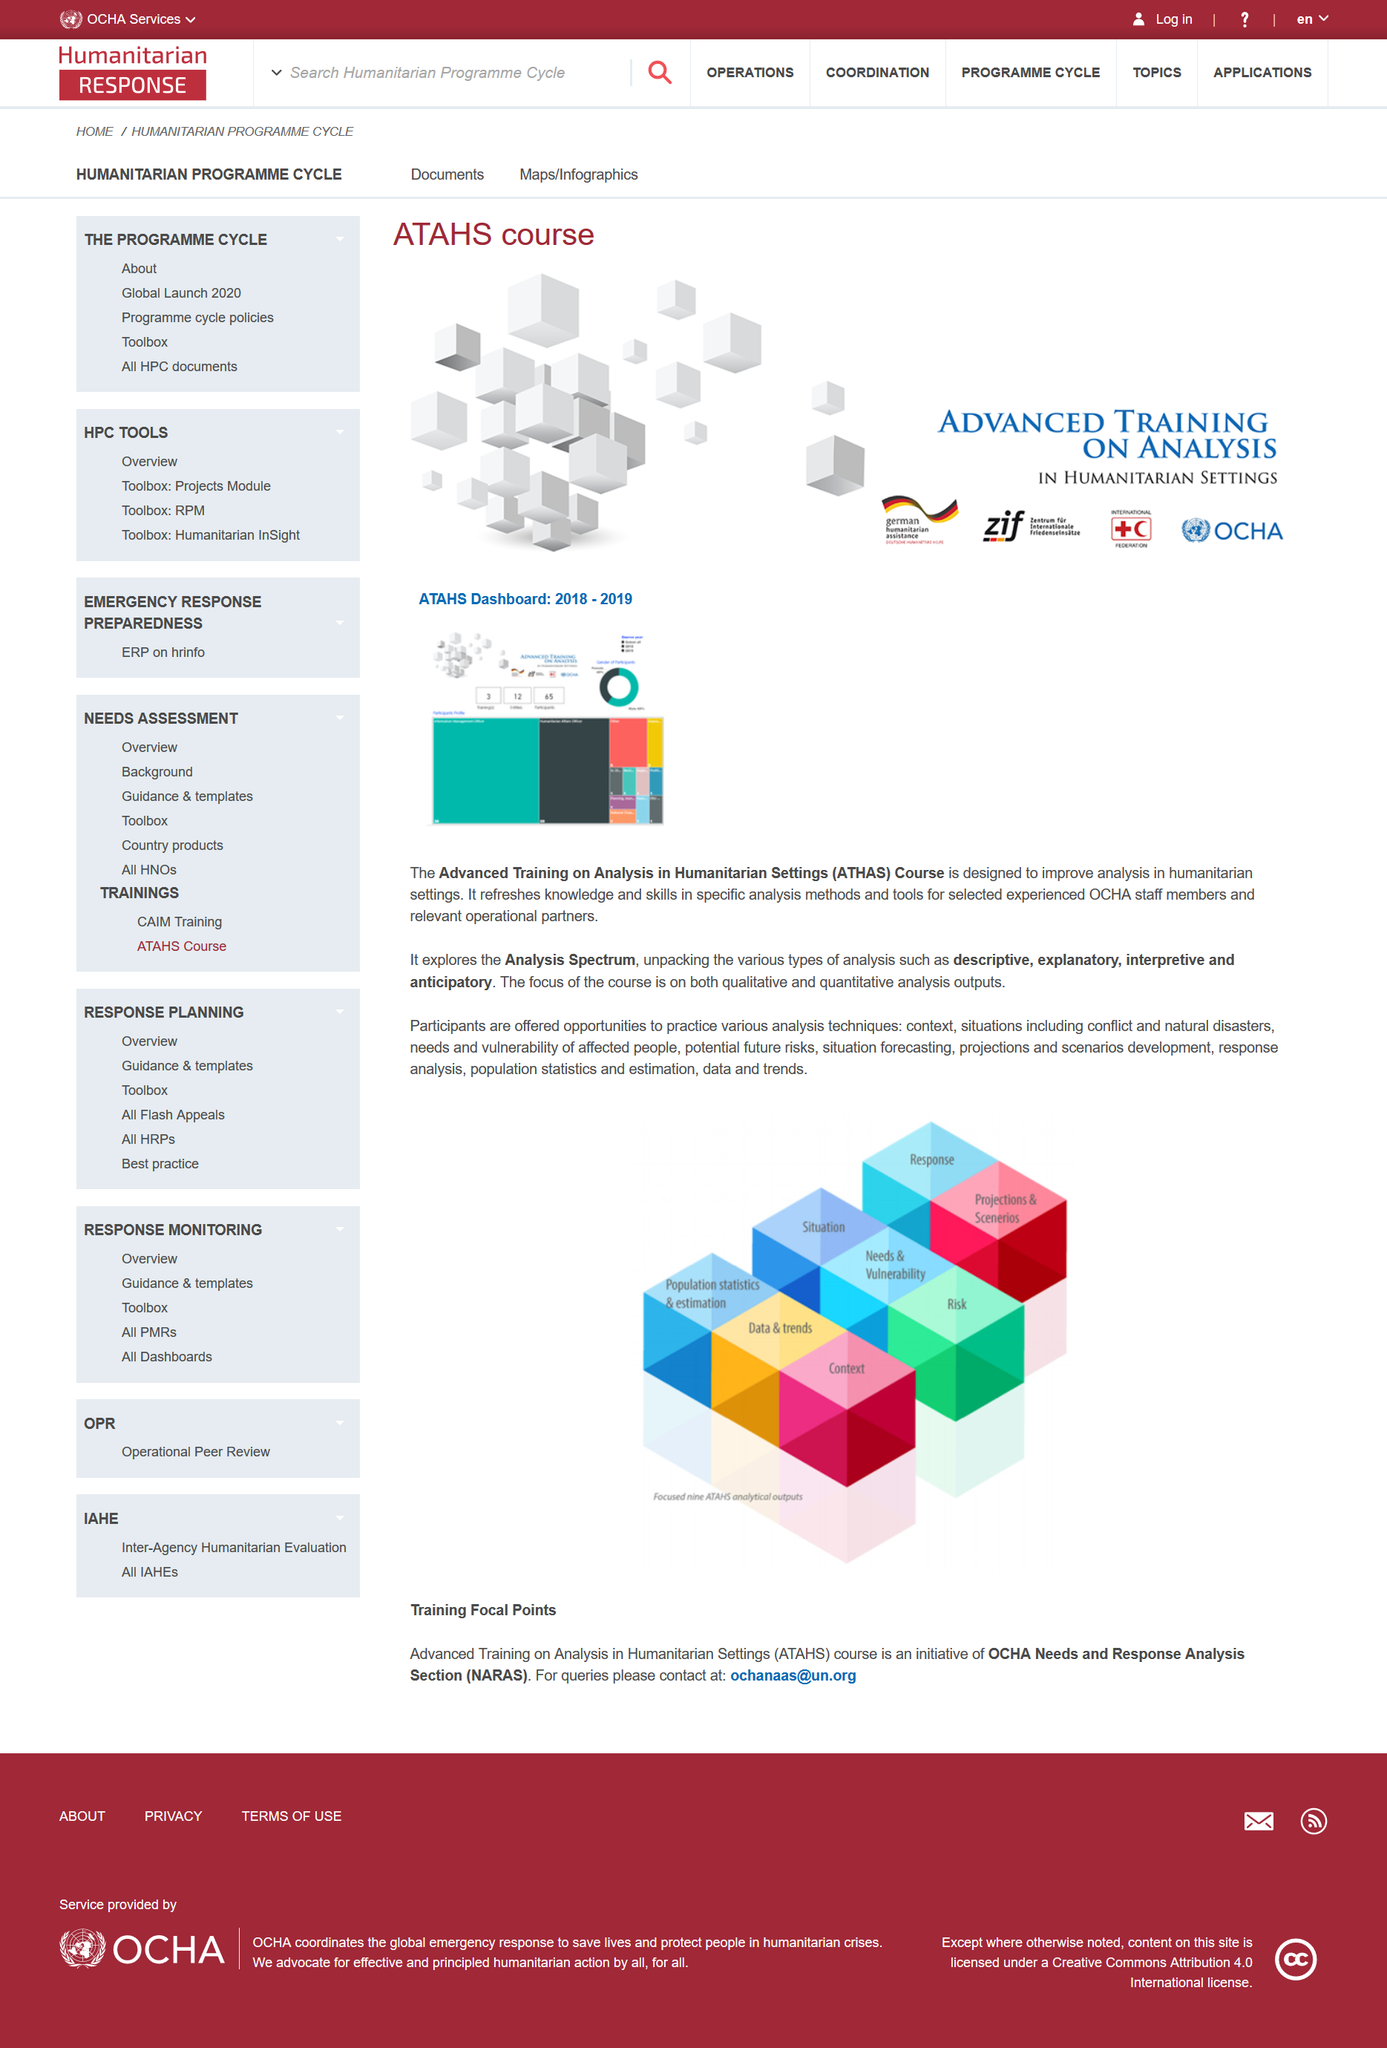Identify some key points in this picture. ATHAS is an initiative of the OCHA needs and response analysis section. The ATHAS course is designed to improve analysis in humanitarian settings. ATHAS provides two types of analytical outputs: risk and situation. 